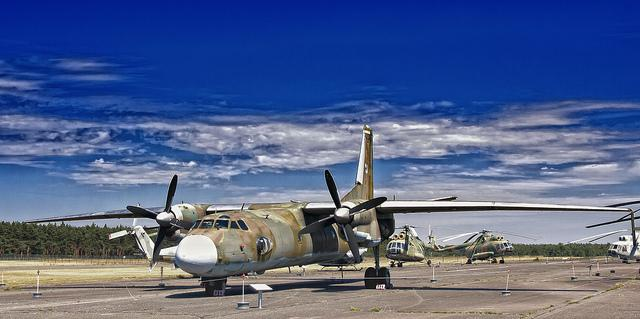What are the four things on each side of the vehicle called? Please explain your reasoning. propellers. These are found on each side of the airplane and it helps the plane move forward. 